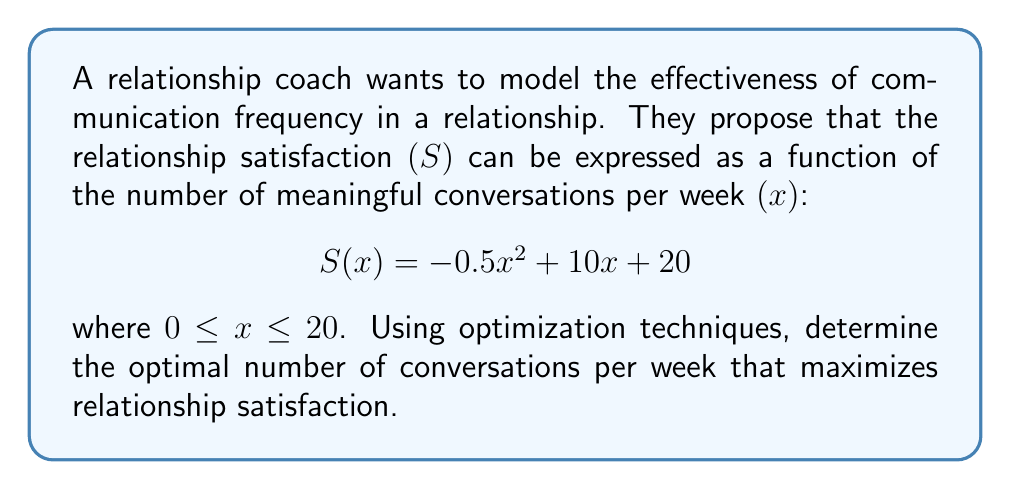Help me with this question. To find the optimal number of conversations that maximizes relationship satisfaction, we need to find the maximum of the function $S(x)$. This can be done using calculus:

1. Find the derivative of $S(x)$:
   $$S'(x) = -x + 10$$

2. Set the derivative equal to zero to find the critical point:
   $$-x + 10 = 0$$
   $$x = 10$$

3. Verify that this critical point is a maximum:
   The second derivative is $S''(x) = -1$, which is negative. This confirms that $x = 10$ is a maximum.

4. Check the endpoints of the domain:
   At $x = 0$: $S(0) = 20$
   At $x = 20$: $S(20) = -0.5(20)^2 + 10(20) + 20 = -200 + 200 + 20 = 20$

5. Compare the values:
   $S(10) = -0.5(10)^2 + 10(10) + 20 = -50 + 100 + 20 = 70$
   This is greater than the values at the endpoints.

Therefore, the optimal number of conversations per week is 10, which yields a maximum relationship satisfaction of 70.
Answer: 10 conversations per week 